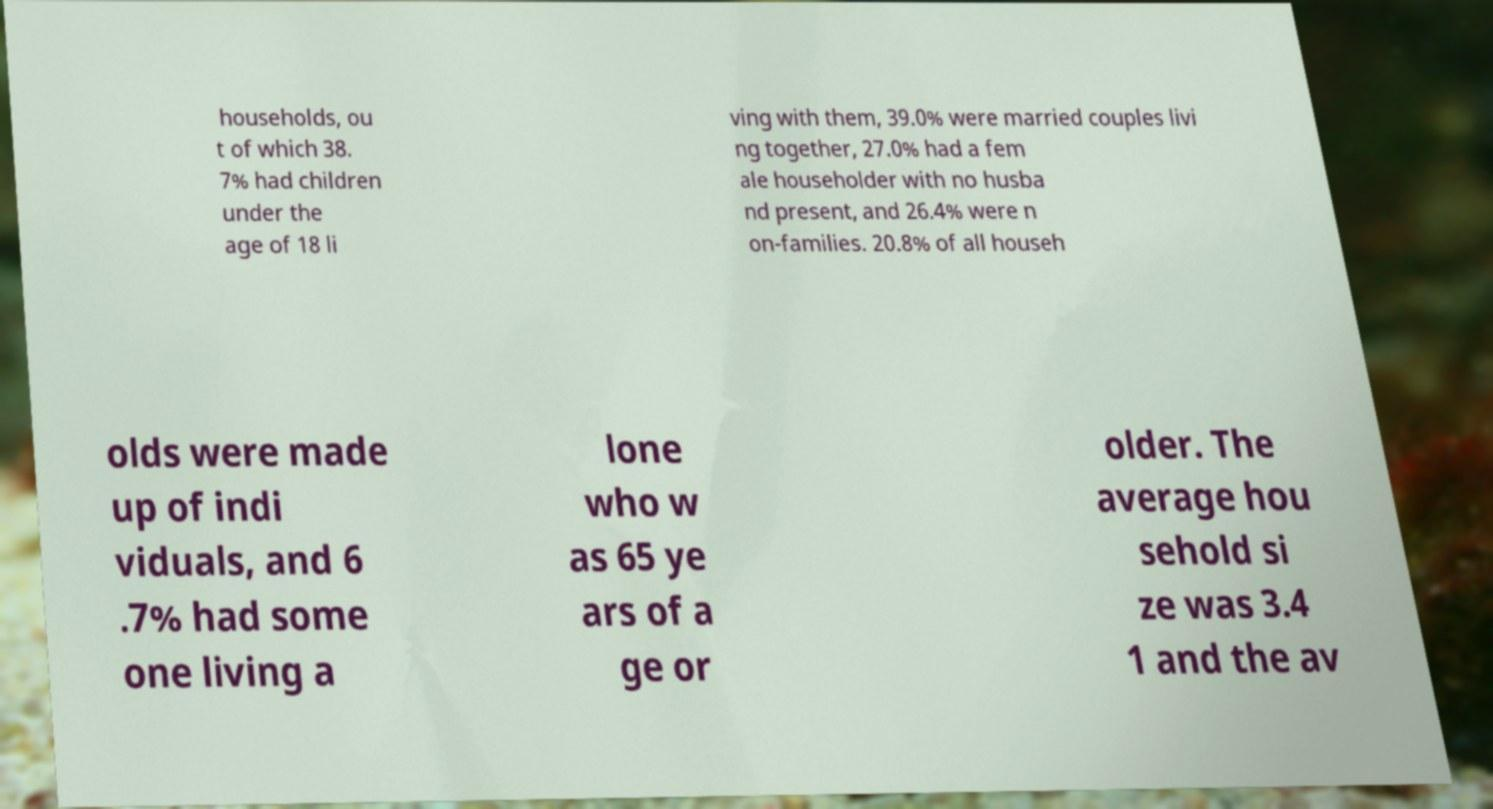Could you extract and type out the text from this image? households, ou t of which 38. 7% had children under the age of 18 li ving with them, 39.0% were married couples livi ng together, 27.0% had a fem ale householder with no husba nd present, and 26.4% were n on-families. 20.8% of all househ olds were made up of indi viduals, and 6 .7% had some one living a lone who w as 65 ye ars of a ge or older. The average hou sehold si ze was 3.4 1 and the av 